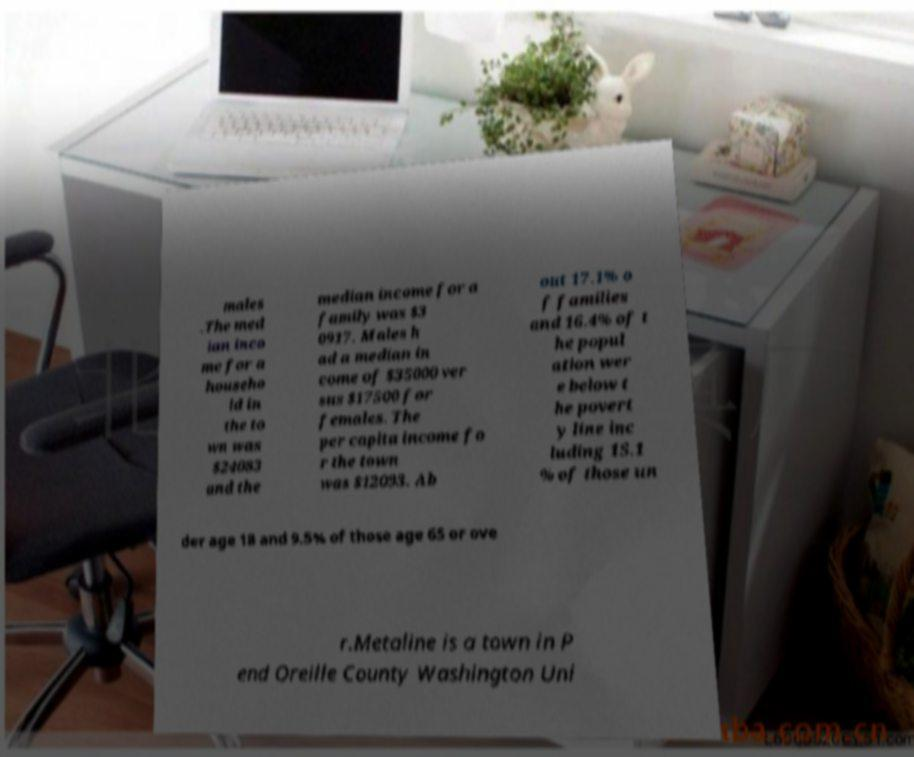Could you extract and type out the text from this image? males .The med ian inco me for a househo ld in the to wn was $24083 and the median income for a family was $3 0917. Males h ad a median in come of $35000 ver sus $17500 for females. The per capita income fo r the town was $12093. Ab out 17.1% o f families and 16.4% of t he popul ation wer e below t he povert y line inc luding 15.1 % of those un der age 18 and 9.5% of those age 65 or ove r.Metaline is a town in P end Oreille County Washington Uni 